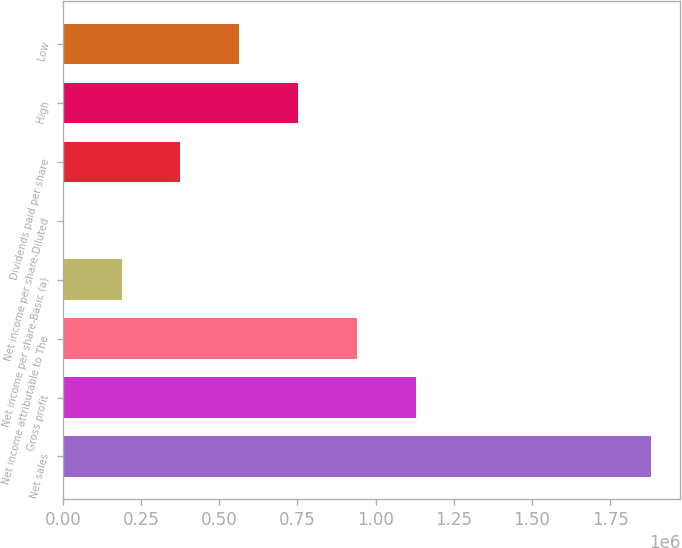Convert chart to OTSL. <chart><loc_0><loc_0><loc_500><loc_500><bar_chart><fcel>Net sales<fcel>Gross profit<fcel>Net income attributable to The<fcel>Net income per share-Basic (a)<fcel>Net income per share-Diluted<fcel>Dividends paid per share<fcel>High<fcel>Low<nl><fcel>1.87968e+06<fcel>1.12781e+06<fcel>939839<fcel>187968<fcel>0.58<fcel>375936<fcel>751872<fcel>563904<nl></chart> 